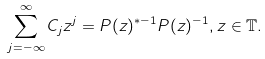Convert formula to latex. <formula><loc_0><loc_0><loc_500><loc_500>\sum _ { j = - \infty } ^ { \infty } C _ { j } z ^ { j } = P ( z ) ^ { * - 1 } P ( z ) ^ { - 1 } , z \in { \mathbb { T } } .</formula> 